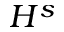Convert formula to latex. <formula><loc_0><loc_0><loc_500><loc_500>H ^ { s }</formula> 